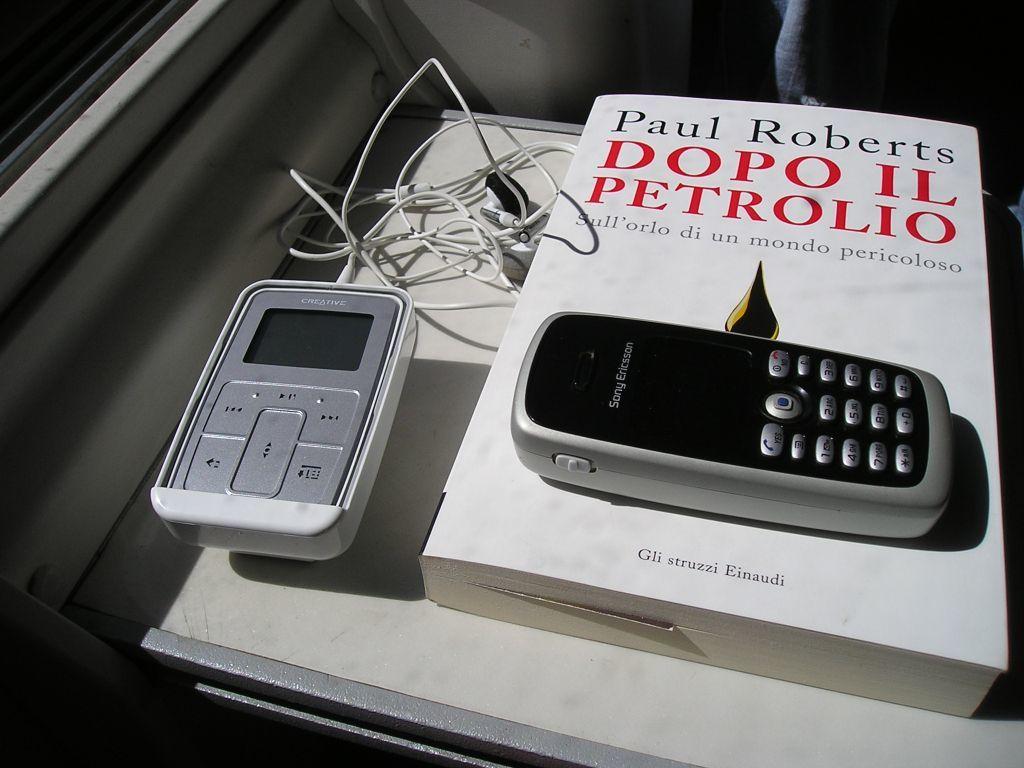Who is the author of the book?
Provide a short and direct response. Paul roberts. What brand is the phone?
Your answer should be very brief. Sony ericsson. 